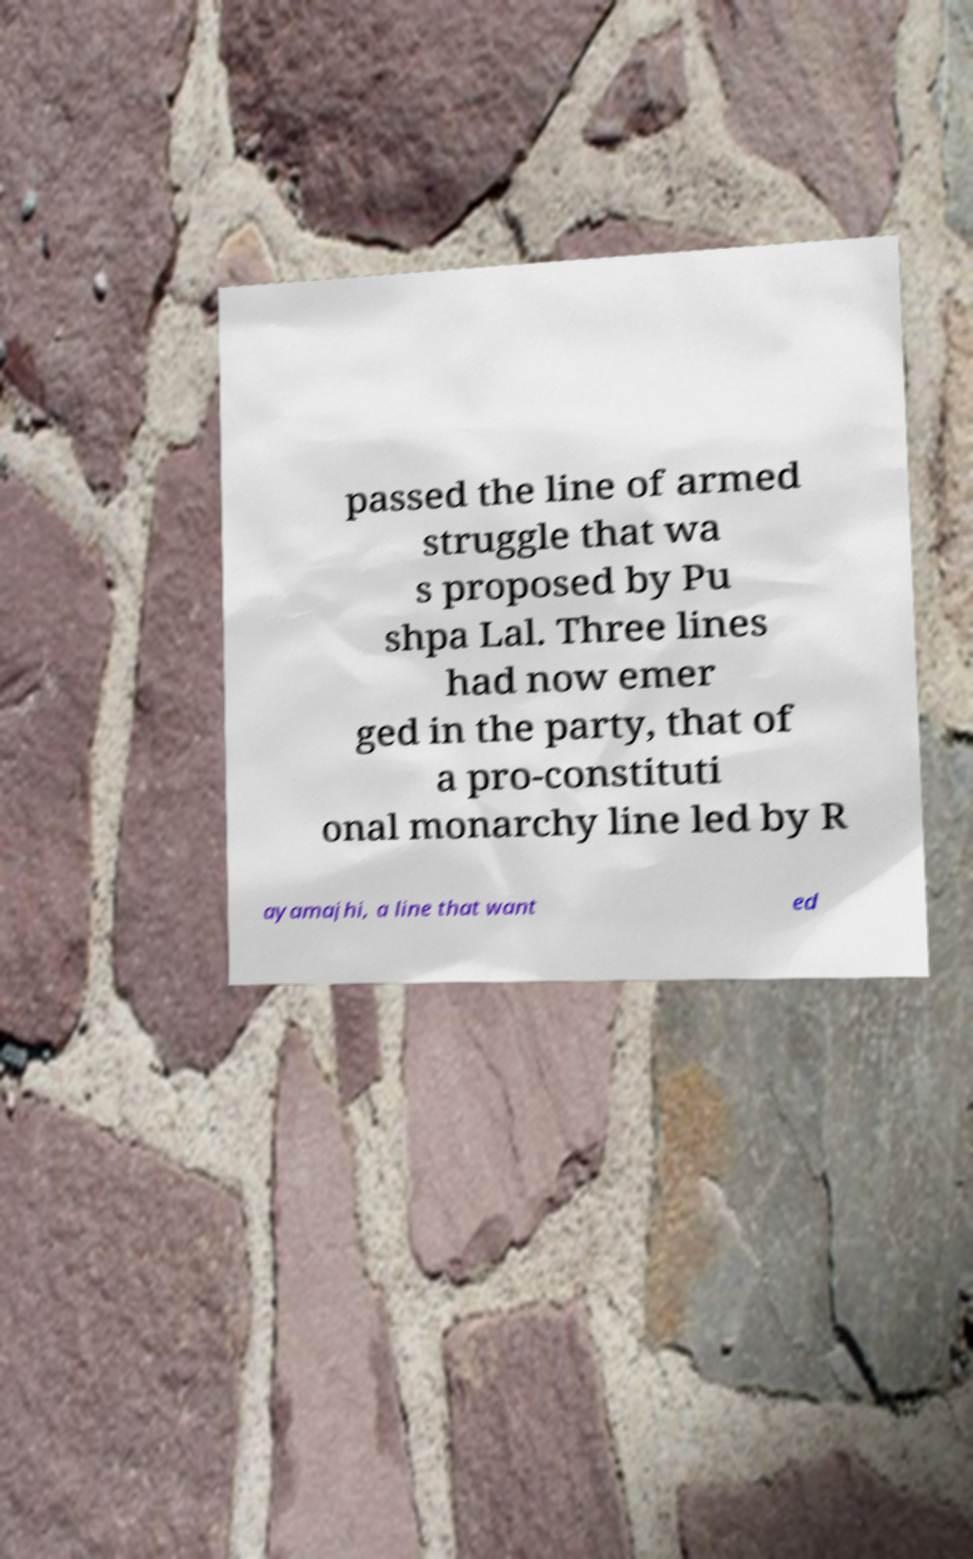For documentation purposes, I need the text within this image transcribed. Could you provide that? passed the line of armed struggle that wa s proposed by Pu shpa Lal. Three lines had now emer ged in the party, that of a pro-constituti onal monarchy line led by R ayamajhi, a line that want ed 